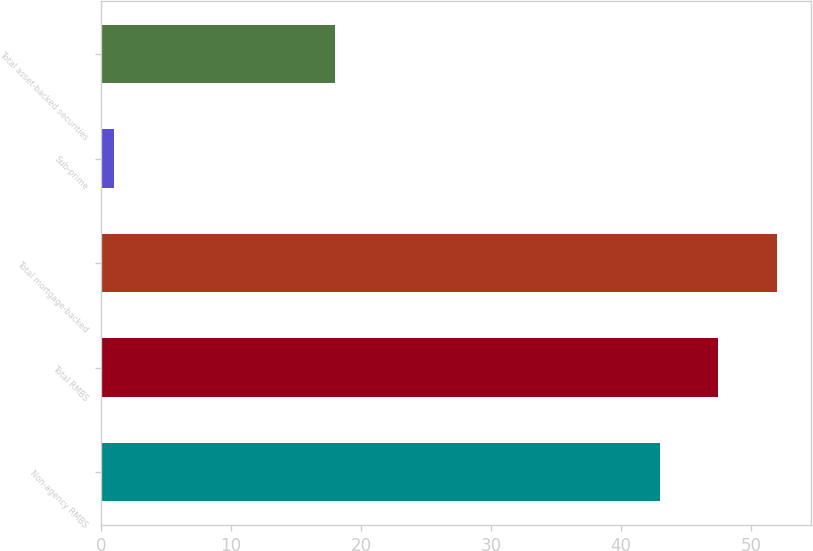Convert chart. <chart><loc_0><loc_0><loc_500><loc_500><bar_chart><fcel>Non-agency RMBS<fcel>Total RMBS<fcel>Total mortgage-backed<fcel>Sub-prime<fcel>Total asset-backed securities<nl><fcel>43<fcel>47.5<fcel>52<fcel>1<fcel>18<nl></chart> 